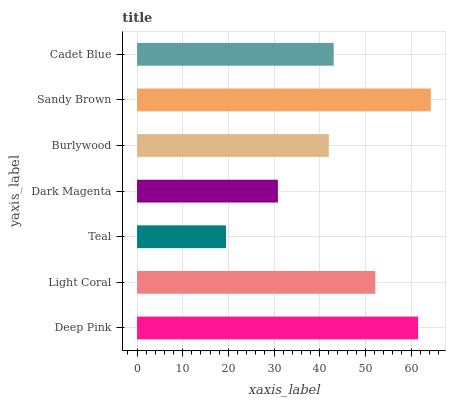Is Teal the minimum?
Answer yes or no. Yes. Is Sandy Brown the maximum?
Answer yes or no. Yes. Is Light Coral the minimum?
Answer yes or no. No. Is Light Coral the maximum?
Answer yes or no. No. Is Deep Pink greater than Light Coral?
Answer yes or no. Yes. Is Light Coral less than Deep Pink?
Answer yes or no. Yes. Is Light Coral greater than Deep Pink?
Answer yes or no. No. Is Deep Pink less than Light Coral?
Answer yes or no. No. Is Cadet Blue the high median?
Answer yes or no. Yes. Is Cadet Blue the low median?
Answer yes or no. Yes. Is Light Coral the high median?
Answer yes or no. No. Is Light Coral the low median?
Answer yes or no. No. 